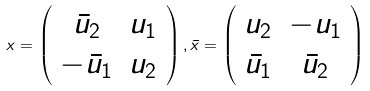Convert formula to latex. <formula><loc_0><loc_0><loc_500><loc_500>x = \left ( \begin{array} { c c } { { \bar { u } _ { 2 } } } & { { u _ { 1 } } } \\ { { - \bar { u } _ { 1 } } } & { { u _ { 2 } } } \end{array} \right ) , \bar { x } = \left ( \begin{array} { c c } { { u _ { 2 } } } & { { - u _ { 1 } } } \\ { { \bar { u } _ { 1 } } } & { { \bar { u } _ { 2 } } } \end{array} \right )</formula> 